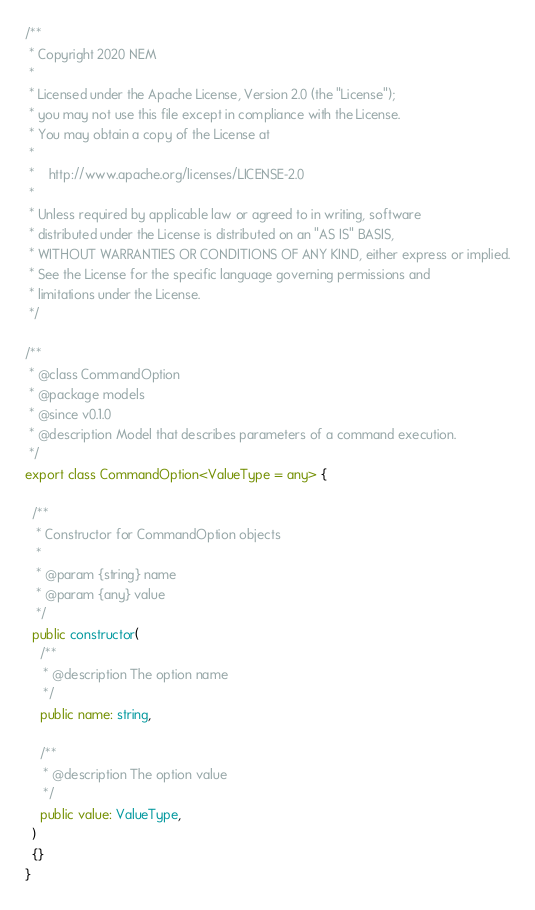<code> <loc_0><loc_0><loc_500><loc_500><_TypeScript_>/**
 * Copyright 2020 NEM
 *
 * Licensed under the Apache License, Version 2.0 (the "License");
 * you may not use this file except in compliance with the License.
 * You may obtain a copy of the License at
 *
 *    http://www.apache.org/licenses/LICENSE-2.0
 *
 * Unless required by applicable law or agreed to in writing, software
 * distributed under the License is distributed on an "AS IS" BASIS,
 * WITHOUT WARRANTIES OR CONDITIONS OF ANY KIND, either express or implied.
 * See the License for the specific language governing permissions and
 * limitations under the License.
 */

/**
 * @class CommandOption
 * @package models
 * @since v0.1.0
 * @description Model that describes parameters of a command execution.
 */
export class CommandOption<ValueType = any> {

  /**
   * Constructor for CommandOption objects
   *
   * @param {string} name
   * @param {any} value
   */
  public constructor(
    /**
     * @description The option name
     */
    public name: string,

    /**
     * @description The option value
     */
    public value: ValueType,
  )
  {}
}
</code> 